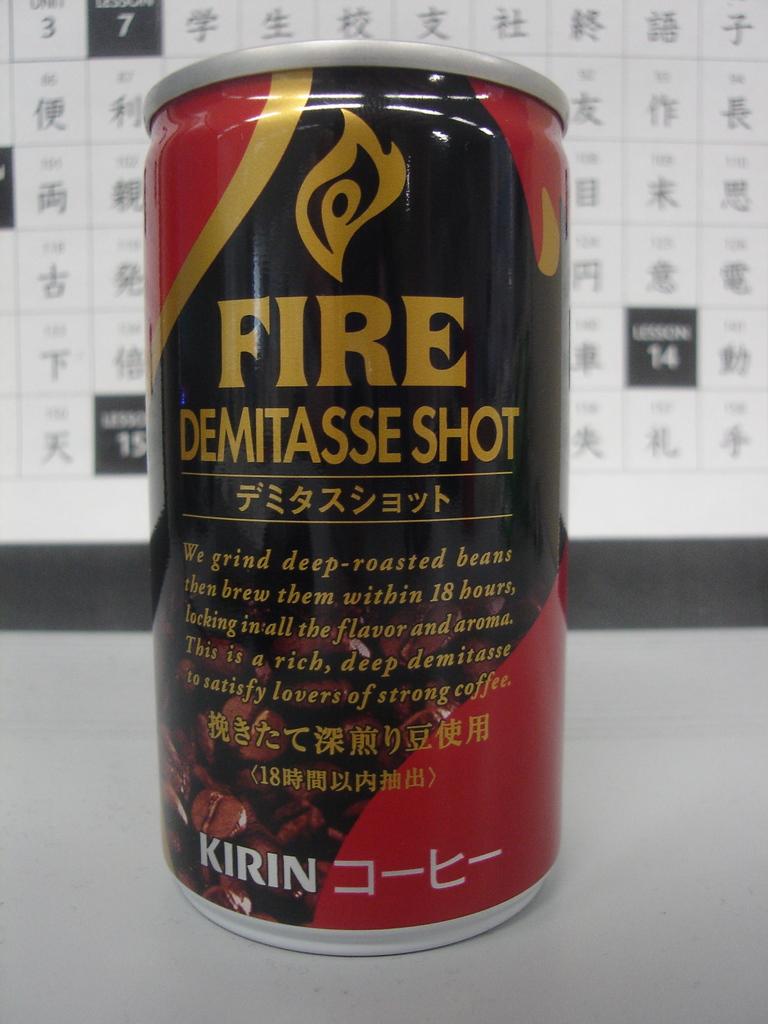Within how many hours are the beans brewed?
Make the answer very short. 18. What brand is this drink?
Make the answer very short. Fire demitasse shot. 